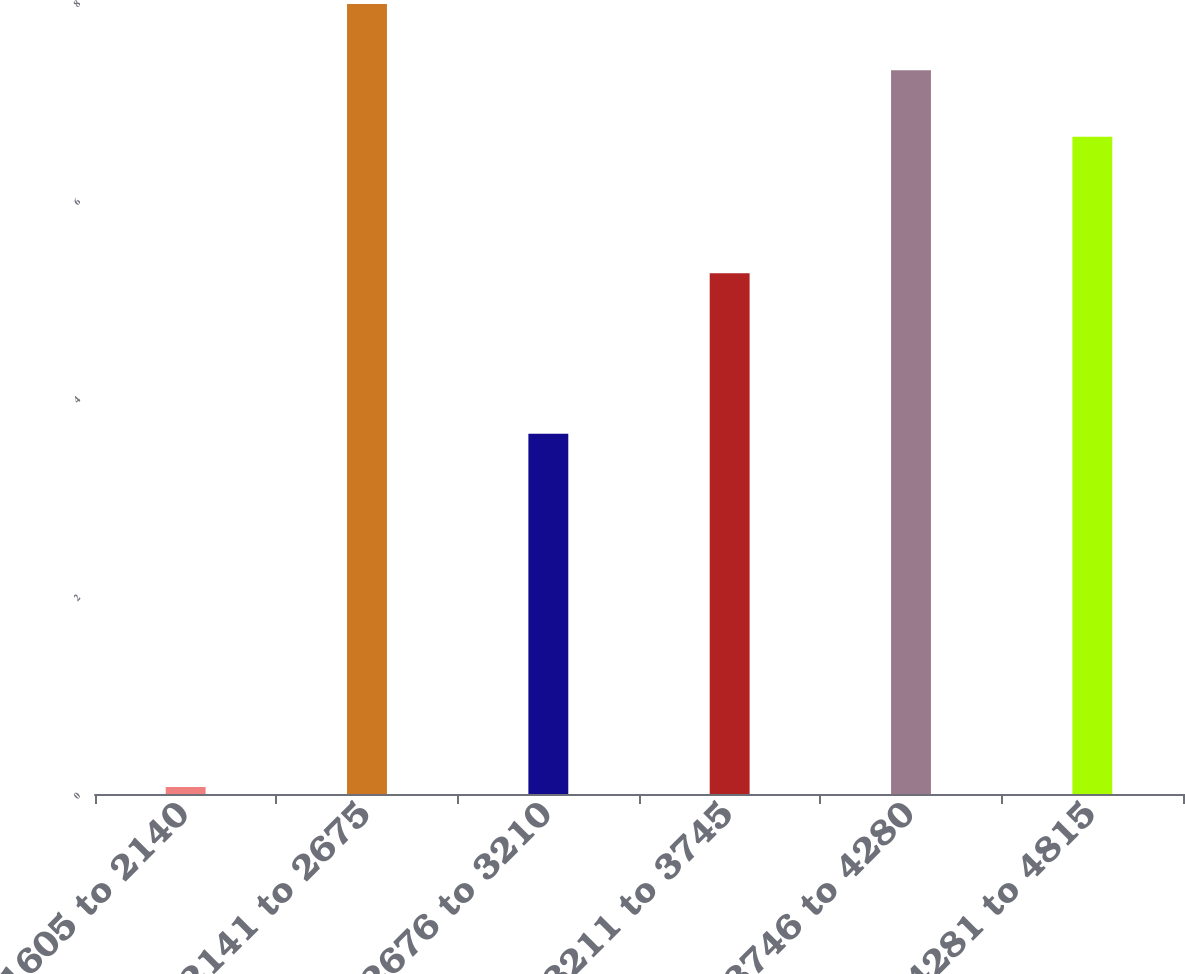Convert chart. <chart><loc_0><loc_0><loc_500><loc_500><bar_chart><fcel>1605 to 2140<fcel>2141 to 2675<fcel>2676 to 3210<fcel>3211 to 3745<fcel>3746 to 4280<fcel>4281 to 4815<nl><fcel>0.07<fcel>7.98<fcel>3.64<fcel>5.26<fcel>7.31<fcel>6.64<nl></chart> 